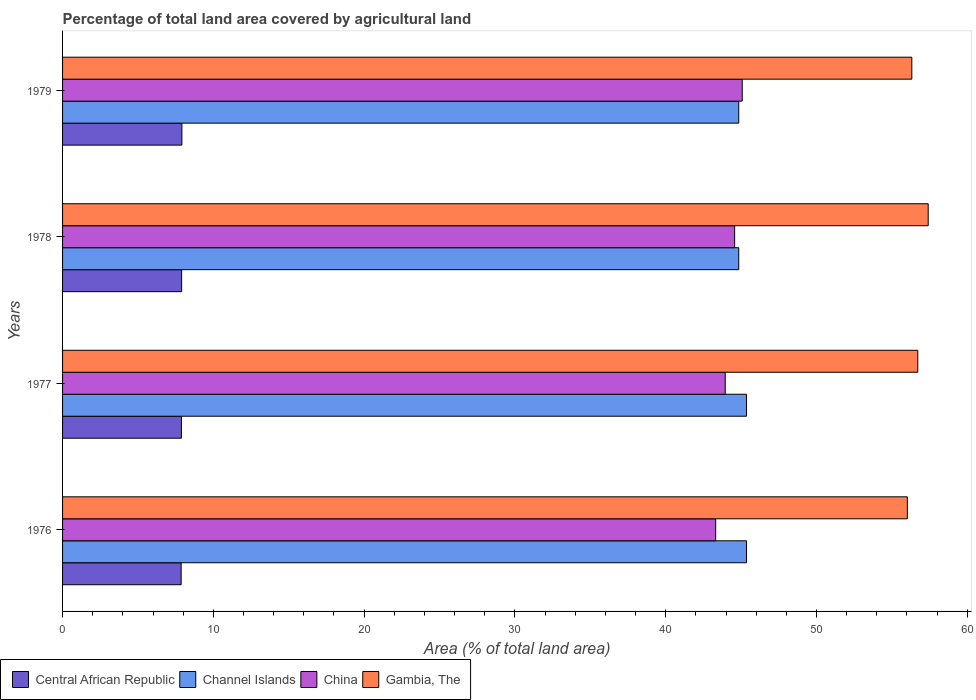Are the number of bars per tick equal to the number of legend labels?
Ensure brevity in your answer.  Yes. How many bars are there on the 4th tick from the top?
Offer a terse response. 4. How many bars are there on the 2nd tick from the bottom?
Your answer should be compact. 4. What is the label of the 2nd group of bars from the top?
Give a very brief answer. 1978. What is the percentage of agricultural land in Central African Republic in 1978?
Your answer should be compact. 7.9. Across all years, what is the maximum percentage of agricultural land in Central African Republic?
Ensure brevity in your answer.  7.91. Across all years, what is the minimum percentage of agricultural land in Channel Islands?
Provide a succinct answer. 44.85. In which year was the percentage of agricultural land in Gambia, The maximum?
Ensure brevity in your answer.  1978. In which year was the percentage of agricultural land in Channel Islands minimum?
Make the answer very short. 1978. What is the total percentage of agricultural land in Gambia, The in the graph?
Keep it short and to the point. 226.48. What is the difference between the percentage of agricultural land in China in 1976 and that in 1977?
Offer a terse response. -0.63. What is the difference between the percentage of agricultural land in Central African Republic in 1979 and the percentage of agricultural land in Gambia, The in 1978?
Provide a short and direct response. -49.5. What is the average percentage of agricultural land in Gambia, The per year?
Make the answer very short. 56.62. In the year 1976, what is the difference between the percentage of agricultural land in Central African Republic and percentage of agricultural land in China?
Ensure brevity in your answer.  -35.45. In how many years, is the percentage of agricultural land in Central African Republic greater than 52 %?
Offer a very short reply. 0. Is the percentage of agricultural land in Channel Islands in 1976 less than that in 1979?
Provide a succinct answer. No. What is the difference between the highest and the second highest percentage of agricultural land in Gambia, The?
Your answer should be compact. 0.69. What is the difference between the highest and the lowest percentage of agricultural land in China?
Offer a terse response. 1.76. Is the sum of the percentage of agricultural land in Central African Republic in 1976 and 1978 greater than the maximum percentage of agricultural land in Gambia, The across all years?
Keep it short and to the point. No. What does the 3rd bar from the top in 1979 represents?
Offer a very short reply. Channel Islands. What does the 4th bar from the bottom in 1976 represents?
Offer a terse response. Gambia, The. Is it the case that in every year, the sum of the percentage of agricultural land in China and percentage of agricultural land in Channel Islands is greater than the percentage of agricultural land in Central African Republic?
Your answer should be compact. Yes. Are all the bars in the graph horizontal?
Your answer should be compact. Yes. What is the difference between two consecutive major ticks on the X-axis?
Provide a short and direct response. 10. Does the graph contain any zero values?
Offer a very short reply. No. Where does the legend appear in the graph?
Keep it short and to the point. Bottom left. How many legend labels are there?
Offer a very short reply. 4. What is the title of the graph?
Offer a very short reply. Percentage of total land area covered by agricultural land. What is the label or title of the X-axis?
Ensure brevity in your answer.  Area (% of total land area). What is the Area (% of total land area) in Central African Republic in 1976?
Offer a terse response. 7.87. What is the Area (% of total land area) of Channel Islands in 1976?
Offer a terse response. 45.36. What is the Area (% of total land area) in China in 1976?
Your response must be concise. 43.32. What is the Area (% of total land area) in Gambia, The in 1976?
Provide a short and direct response. 56.03. What is the Area (% of total land area) of Central African Republic in 1977?
Your answer should be compact. 7.88. What is the Area (% of total land area) of Channel Islands in 1977?
Your answer should be very brief. 45.36. What is the Area (% of total land area) in China in 1977?
Your answer should be very brief. 43.95. What is the Area (% of total land area) in Gambia, The in 1977?
Keep it short and to the point. 56.72. What is the Area (% of total land area) in Central African Republic in 1978?
Provide a short and direct response. 7.9. What is the Area (% of total land area) in Channel Islands in 1978?
Ensure brevity in your answer.  44.85. What is the Area (% of total land area) of China in 1978?
Keep it short and to the point. 44.57. What is the Area (% of total land area) of Gambia, The in 1978?
Make the answer very short. 57.41. What is the Area (% of total land area) in Central African Republic in 1979?
Make the answer very short. 7.91. What is the Area (% of total land area) in Channel Islands in 1979?
Keep it short and to the point. 44.85. What is the Area (% of total land area) in China in 1979?
Your response must be concise. 45.08. What is the Area (% of total land area) of Gambia, The in 1979?
Your answer should be compact. 56.32. Across all years, what is the maximum Area (% of total land area) in Central African Republic?
Ensure brevity in your answer.  7.91. Across all years, what is the maximum Area (% of total land area) in Channel Islands?
Your answer should be compact. 45.36. Across all years, what is the maximum Area (% of total land area) in China?
Provide a succinct answer. 45.08. Across all years, what is the maximum Area (% of total land area) in Gambia, The?
Your answer should be compact. 57.41. Across all years, what is the minimum Area (% of total land area) of Central African Republic?
Ensure brevity in your answer.  7.87. Across all years, what is the minimum Area (% of total land area) in Channel Islands?
Your answer should be very brief. 44.85. Across all years, what is the minimum Area (% of total land area) in China?
Ensure brevity in your answer.  43.32. Across all years, what is the minimum Area (% of total land area) of Gambia, The?
Your answer should be very brief. 56.03. What is the total Area (% of total land area) of Central African Republic in the graph?
Offer a very short reply. 31.56. What is the total Area (% of total land area) of Channel Islands in the graph?
Your response must be concise. 180.41. What is the total Area (% of total land area) in China in the graph?
Your response must be concise. 176.91. What is the total Area (% of total land area) in Gambia, The in the graph?
Provide a short and direct response. 226.48. What is the difference between the Area (% of total land area) of Central African Republic in 1976 and that in 1977?
Offer a very short reply. -0.02. What is the difference between the Area (% of total land area) in China in 1976 and that in 1977?
Your response must be concise. -0.63. What is the difference between the Area (% of total land area) of Gambia, The in 1976 and that in 1977?
Provide a short and direct response. -0.69. What is the difference between the Area (% of total land area) of Central African Republic in 1976 and that in 1978?
Offer a terse response. -0.03. What is the difference between the Area (% of total land area) in Channel Islands in 1976 and that in 1978?
Make the answer very short. 0.52. What is the difference between the Area (% of total land area) in China in 1976 and that in 1978?
Offer a terse response. -1.26. What is the difference between the Area (% of total land area) in Gambia, The in 1976 and that in 1978?
Provide a succinct answer. -1.38. What is the difference between the Area (% of total land area) of Central African Republic in 1976 and that in 1979?
Provide a short and direct response. -0.05. What is the difference between the Area (% of total land area) of Channel Islands in 1976 and that in 1979?
Your answer should be very brief. 0.52. What is the difference between the Area (% of total land area) of China in 1976 and that in 1979?
Give a very brief answer. -1.76. What is the difference between the Area (% of total land area) of Gambia, The in 1976 and that in 1979?
Offer a very short reply. -0.3. What is the difference between the Area (% of total land area) of Central African Republic in 1977 and that in 1978?
Your response must be concise. -0.02. What is the difference between the Area (% of total land area) of Channel Islands in 1977 and that in 1978?
Offer a terse response. 0.52. What is the difference between the Area (% of total land area) of China in 1977 and that in 1978?
Offer a very short reply. -0.63. What is the difference between the Area (% of total land area) of Gambia, The in 1977 and that in 1978?
Give a very brief answer. -0.69. What is the difference between the Area (% of total land area) in Central African Republic in 1977 and that in 1979?
Give a very brief answer. -0.03. What is the difference between the Area (% of total land area) in Channel Islands in 1977 and that in 1979?
Ensure brevity in your answer.  0.52. What is the difference between the Area (% of total land area) of China in 1977 and that in 1979?
Your answer should be compact. -1.13. What is the difference between the Area (% of total land area) of Gambia, The in 1977 and that in 1979?
Give a very brief answer. 0.4. What is the difference between the Area (% of total land area) of Central African Republic in 1978 and that in 1979?
Provide a succinct answer. -0.02. What is the difference between the Area (% of total land area) in China in 1978 and that in 1979?
Your answer should be very brief. -0.5. What is the difference between the Area (% of total land area) in Gambia, The in 1978 and that in 1979?
Offer a terse response. 1.09. What is the difference between the Area (% of total land area) in Central African Republic in 1976 and the Area (% of total land area) in Channel Islands in 1977?
Offer a very short reply. -37.5. What is the difference between the Area (% of total land area) of Central African Republic in 1976 and the Area (% of total land area) of China in 1977?
Provide a succinct answer. -36.08. What is the difference between the Area (% of total land area) of Central African Republic in 1976 and the Area (% of total land area) of Gambia, The in 1977?
Your answer should be very brief. -48.85. What is the difference between the Area (% of total land area) of Channel Islands in 1976 and the Area (% of total land area) of China in 1977?
Give a very brief answer. 1.41. What is the difference between the Area (% of total land area) of Channel Islands in 1976 and the Area (% of total land area) of Gambia, The in 1977?
Offer a terse response. -11.36. What is the difference between the Area (% of total land area) of China in 1976 and the Area (% of total land area) of Gambia, The in 1977?
Make the answer very short. -13.4. What is the difference between the Area (% of total land area) in Central African Republic in 1976 and the Area (% of total land area) in Channel Islands in 1978?
Keep it short and to the point. -36.98. What is the difference between the Area (% of total land area) of Central African Republic in 1976 and the Area (% of total land area) of China in 1978?
Your answer should be compact. -36.71. What is the difference between the Area (% of total land area) in Central African Republic in 1976 and the Area (% of total land area) in Gambia, The in 1978?
Your answer should be compact. -49.55. What is the difference between the Area (% of total land area) in Channel Islands in 1976 and the Area (% of total land area) in China in 1978?
Provide a succinct answer. 0.79. What is the difference between the Area (% of total land area) of Channel Islands in 1976 and the Area (% of total land area) of Gambia, The in 1978?
Make the answer very short. -12.05. What is the difference between the Area (% of total land area) of China in 1976 and the Area (% of total land area) of Gambia, The in 1978?
Your response must be concise. -14.1. What is the difference between the Area (% of total land area) in Central African Republic in 1976 and the Area (% of total land area) in Channel Islands in 1979?
Give a very brief answer. -36.98. What is the difference between the Area (% of total land area) in Central African Republic in 1976 and the Area (% of total land area) in China in 1979?
Make the answer very short. -37.21. What is the difference between the Area (% of total land area) of Central African Republic in 1976 and the Area (% of total land area) of Gambia, The in 1979?
Your answer should be compact. -48.46. What is the difference between the Area (% of total land area) of Channel Islands in 1976 and the Area (% of total land area) of China in 1979?
Make the answer very short. 0.28. What is the difference between the Area (% of total land area) of Channel Islands in 1976 and the Area (% of total land area) of Gambia, The in 1979?
Ensure brevity in your answer.  -10.96. What is the difference between the Area (% of total land area) in China in 1976 and the Area (% of total land area) in Gambia, The in 1979?
Your answer should be compact. -13.01. What is the difference between the Area (% of total land area) of Central African Republic in 1977 and the Area (% of total land area) of Channel Islands in 1978?
Give a very brief answer. -36.96. What is the difference between the Area (% of total land area) in Central African Republic in 1977 and the Area (% of total land area) in China in 1978?
Provide a succinct answer. -36.69. What is the difference between the Area (% of total land area) of Central African Republic in 1977 and the Area (% of total land area) of Gambia, The in 1978?
Offer a very short reply. -49.53. What is the difference between the Area (% of total land area) in Channel Islands in 1977 and the Area (% of total land area) in China in 1978?
Your answer should be compact. 0.79. What is the difference between the Area (% of total land area) of Channel Islands in 1977 and the Area (% of total land area) of Gambia, The in 1978?
Offer a very short reply. -12.05. What is the difference between the Area (% of total land area) in China in 1977 and the Area (% of total land area) in Gambia, The in 1978?
Offer a very short reply. -13.46. What is the difference between the Area (% of total land area) of Central African Republic in 1977 and the Area (% of total land area) of Channel Islands in 1979?
Your answer should be compact. -36.96. What is the difference between the Area (% of total land area) of Central African Republic in 1977 and the Area (% of total land area) of China in 1979?
Give a very brief answer. -37.2. What is the difference between the Area (% of total land area) in Central African Republic in 1977 and the Area (% of total land area) in Gambia, The in 1979?
Offer a very short reply. -48.44. What is the difference between the Area (% of total land area) of Channel Islands in 1977 and the Area (% of total land area) of China in 1979?
Offer a terse response. 0.28. What is the difference between the Area (% of total land area) of Channel Islands in 1977 and the Area (% of total land area) of Gambia, The in 1979?
Keep it short and to the point. -10.96. What is the difference between the Area (% of total land area) in China in 1977 and the Area (% of total land area) in Gambia, The in 1979?
Ensure brevity in your answer.  -12.38. What is the difference between the Area (% of total land area) of Central African Republic in 1978 and the Area (% of total land area) of Channel Islands in 1979?
Your answer should be very brief. -36.95. What is the difference between the Area (% of total land area) in Central African Republic in 1978 and the Area (% of total land area) in China in 1979?
Your answer should be compact. -37.18. What is the difference between the Area (% of total land area) of Central African Republic in 1978 and the Area (% of total land area) of Gambia, The in 1979?
Offer a terse response. -48.43. What is the difference between the Area (% of total land area) of Channel Islands in 1978 and the Area (% of total land area) of China in 1979?
Your answer should be compact. -0.23. What is the difference between the Area (% of total land area) of Channel Islands in 1978 and the Area (% of total land area) of Gambia, The in 1979?
Offer a very short reply. -11.48. What is the difference between the Area (% of total land area) in China in 1978 and the Area (% of total land area) in Gambia, The in 1979?
Ensure brevity in your answer.  -11.75. What is the average Area (% of total land area) in Central African Republic per year?
Provide a succinct answer. 7.89. What is the average Area (% of total land area) in Channel Islands per year?
Keep it short and to the point. 45.1. What is the average Area (% of total land area) in China per year?
Keep it short and to the point. 44.23. What is the average Area (% of total land area) in Gambia, The per year?
Ensure brevity in your answer.  56.62. In the year 1976, what is the difference between the Area (% of total land area) of Central African Republic and Area (% of total land area) of Channel Islands?
Give a very brief answer. -37.5. In the year 1976, what is the difference between the Area (% of total land area) of Central African Republic and Area (% of total land area) of China?
Provide a succinct answer. -35.45. In the year 1976, what is the difference between the Area (% of total land area) of Central African Republic and Area (% of total land area) of Gambia, The?
Give a very brief answer. -48.16. In the year 1976, what is the difference between the Area (% of total land area) in Channel Islands and Area (% of total land area) in China?
Offer a terse response. 2.04. In the year 1976, what is the difference between the Area (% of total land area) in Channel Islands and Area (% of total land area) in Gambia, The?
Provide a short and direct response. -10.67. In the year 1976, what is the difference between the Area (% of total land area) in China and Area (% of total land area) in Gambia, The?
Your answer should be very brief. -12.71. In the year 1977, what is the difference between the Area (% of total land area) of Central African Republic and Area (% of total land area) of Channel Islands?
Your response must be concise. -37.48. In the year 1977, what is the difference between the Area (% of total land area) of Central African Republic and Area (% of total land area) of China?
Offer a terse response. -36.07. In the year 1977, what is the difference between the Area (% of total land area) in Central African Republic and Area (% of total land area) in Gambia, The?
Offer a very short reply. -48.84. In the year 1977, what is the difference between the Area (% of total land area) of Channel Islands and Area (% of total land area) of China?
Provide a short and direct response. 1.41. In the year 1977, what is the difference between the Area (% of total land area) of Channel Islands and Area (% of total land area) of Gambia, The?
Offer a terse response. -11.36. In the year 1977, what is the difference between the Area (% of total land area) in China and Area (% of total land area) in Gambia, The?
Offer a terse response. -12.77. In the year 1978, what is the difference between the Area (% of total land area) in Central African Republic and Area (% of total land area) in Channel Islands?
Keep it short and to the point. -36.95. In the year 1978, what is the difference between the Area (% of total land area) of Central African Republic and Area (% of total land area) of China?
Your answer should be compact. -36.68. In the year 1978, what is the difference between the Area (% of total land area) in Central African Republic and Area (% of total land area) in Gambia, The?
Offer a very short reply. -49.51. In the year 1978, what is the difference between the Area (% of total land area) of Channel Islands and Area (% of total land area) of China?
Provide a succinct answer. 0.27. In the year 1978, what is the difference between the Area (% of total land area) of Channel Islands and Area (% of total land area) of Gambia, The?
Your answer should be compact. -12.57. In the year 1978, what is the difference between the Area (% of total land area) of China and Area (% of total land area) of Gambia, The?
Provide a short and direct response. -12.84. In the year 1979, what is the difference between the Area (% of total land area) of Central African Republic and Area (% of total land area) of Channel Islands?
Give a very brief answer. -36.93. In the year 1979, what is the difference between the Area (% of total land area) of Central African Republic and Area (% of total land area) of China?
Ensure brevity in your answer.  -37.16. In the year 1979, what is the difference between the Area (% of total land area) in Central African Republic and Area (% of total land area) in Gambia, The?
Your answer should be compact. -48.41. In the year 1979, what is the difference between the Area (% of total land area) in Channel Islands and Area (% of total land area) in China?
Your answer should be compact. -0.23. In the year 1979, what is the difference between the Area (% of total land area) in Channel Islands and Area (% of total land area) in Gambia, The?
Make the answer very short. -11.48. In the year 1979, what is the difference between the Area (% of total land area) in China and Area (% of total land area) in Gambia, The?
Offer a very short reply. -11.25. What is the ratio of the Area (% of total land area) of Central African Republic in 1976 to that in 1977?
Offer a very short reply. 1. What is the ratio of the Area (% of total land area) of China in 1976 to that in 1977?
Your answer should be compact. 0.99. What is the ratio of the Area (% of total land area) in Gambia, The in 1976 to that in 1977?
Provide a succinct answer. 0.99. What is the ratio of the Area (% of total land area) in Channel Islands in 1976 to that in 1978?
Your response must be concise. 1.01. What is the ratio of the Area (% of total land area) in China in 1976 to that in 1978?
Ensure brevity in your answer.  0.97. What is the ratio of the Area (% of total land area) in Gambia, The in 1976 to that in 1978?
Your answer should be very brief. 0.98. What is the ratio of the Area (% of total land area) of Channel Islands in 1976 to that in 1979?
Make the answer very short. 1.01. What is the ratio of the Area (% of total land area) in China in 1976 to that in 1979?
Ensure brevity in your answer.  0.96. What is the ratio of the Area (% of total land area) of Gambia, The in 1976 to that in 1979?
Your answer should be very brief. 0.99. What is the ratio of the Area (% of total land area) in Channel Islands in 1977 to that in 1978?
Give a very brief answer. 1.01. What is the ratio of the Area (% of total land area) in China in 1977 to that in 1978?
Your answer should be compact. 0.99. What is the ratio of the Area (% of total land area) of Gambia, The in 1977 to that in 1978?
Offer a terse response. 0.99. What is the ratio of the Area (% of total land area) of Central African Republic in 1977 to that in 1979?
Offer a terse response. 1. What is the ratio of the Area (% of total land area) in Channel Islands in 1977 to that in 1979?
Your response must be concise. 1.01. What is the ratio of the Area (% of total land area) of China in 1977 to that in 1979?
Provide a succinct answer. 0.97. What is the ratio of the Area (% of total land area) of Gambia, The in 1977 to that in 1979?
Ensure brevity in your answer.  1.01. What is the ratio of the Area (% of total land area) in Central African Republic in 1978 to that in 1979?
Ensure brevity in your answer.  1. What is the ratio of the Area (% of total land area) of China in 1978 to that in 1979?
Keep it short and to the point. 0.99. What is the ratio of the Area (% of total land area) in Gambia, The in 1978 to that in 1979?
Keep it short and to the point. 1.02. What is the difference between the highest and the second highest Area (% of total land area) of Central African Republic?
Offer a very short reply. 0.02. What is the difference between the highest and the second highest Area (% of total land area) in Channel Islands?
Your response must be concise. 0. What is the difference between the highest and the second highest Area (% of total land area) of China?
Provide a succinct answer. 0.5. What is the difference between the highest and the second highest Area (% of total land area) of Gambia, The?
Make the answer very short. 0.69. What is the difference between the highest and the lowest Area (% of total land area) in Central African Republic?
Provide a short and direct response. 0.05. What is the difference between the highest and the lowest Area (% of total land area) of Channel Islands?
Keep it short and to the point. 0.52. What is the difference between the highest and the lowest Area (% of total land area) of China?
Your answer should be very brief. 1.76. What is the difference between the highest and the lowest Area (% of total land area) of Gambia, The?
Ensure brevity in your answer.  1.38. 